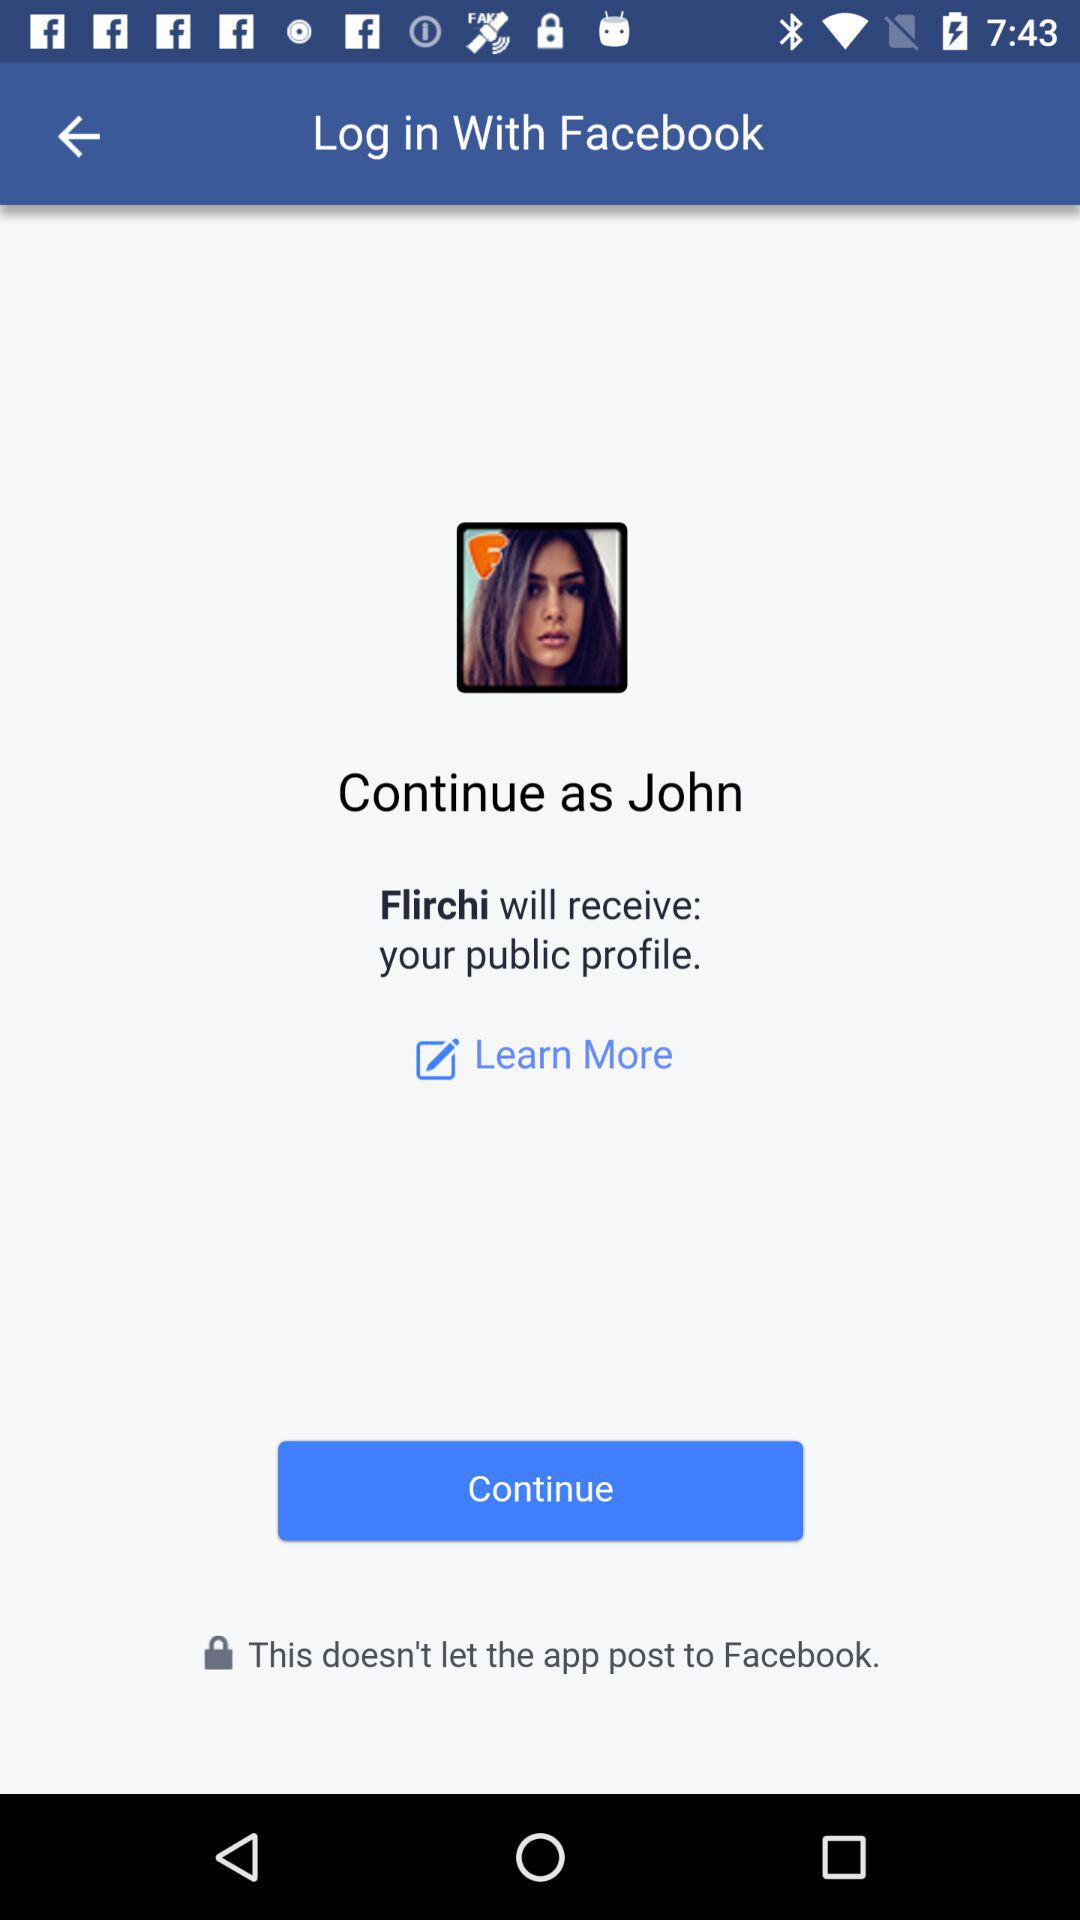What is the name of the user? The name of the user is John. 